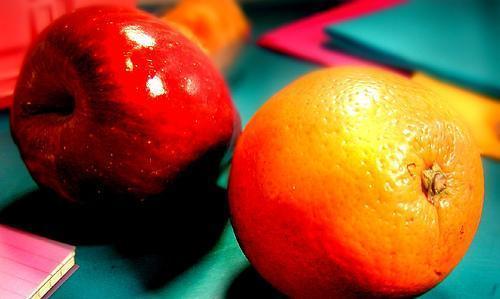How many fruit are in the picture?
Give a very brief answer. 2. 